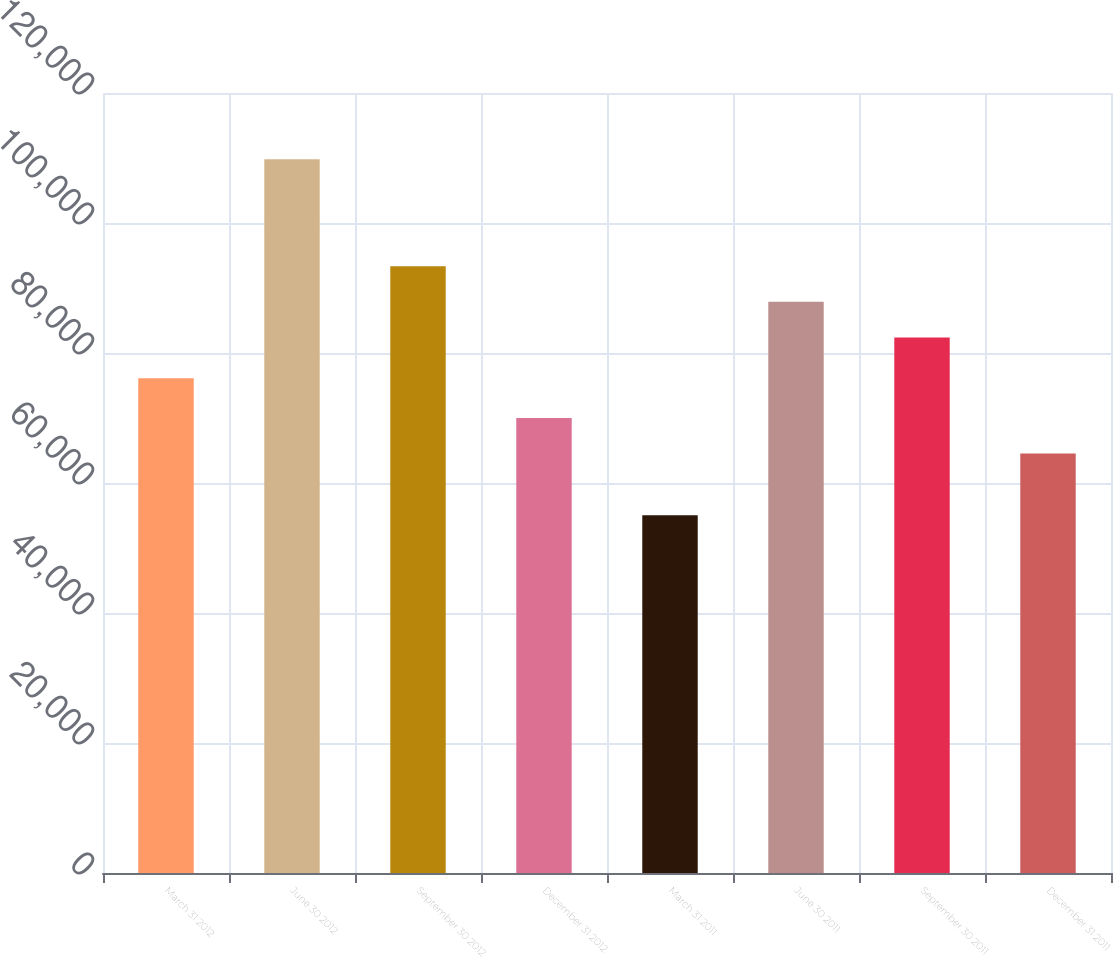<chart> <loc_0><loc_0><loc_500><loc_500><bar_chart><fcel>March 31 2012<fcel>June 30 2012<fcel>September 30 2012<fcel>December 31 2012<fcel>March 31 2011<fcel>June 30 2011<fcel>September 30 2011<fcel>December 31 2011<nl><fcel>76099<fcel>109795<fcel>93342.4<fcel>70011.2<fcel>55043<fcel>87867.2<fcel>82392<fcel>64536<nl></chart> 